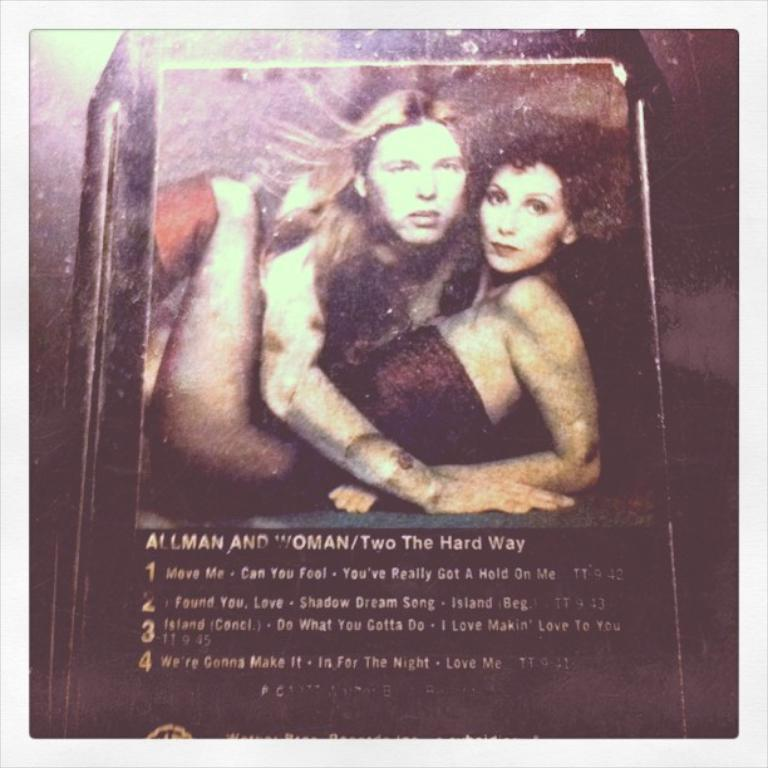What is the main subject of the image? The main subject of the image is a frame. Where is the kettle located in the image? There is no kettle present in the image. What type of police officer is depicted in the image? There is no police officer present in the image. Who is the creator of the frame in the image? The fact provided does not give any information about the creator of the frame, so it cannot be determined from the image. 